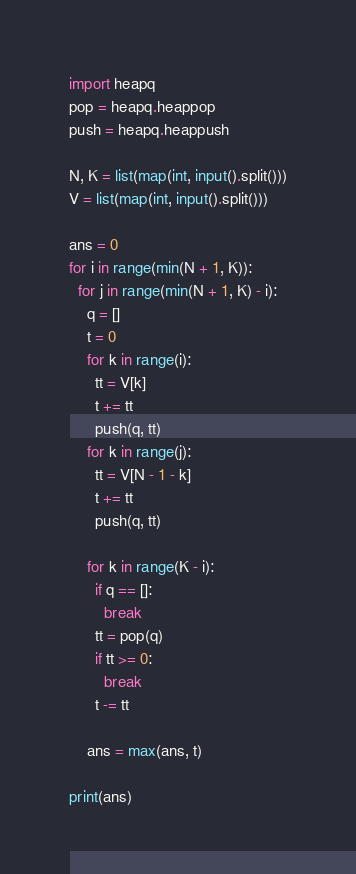Convert code to text. <code><loc_0><loc_0><loc_500><loc_500><_Python_>import heapq
pop = heapq.heappop
push = heapq.heappush

N, K = list(map(int, input().split()))
V = list(map(int, input().split()))

ans = 0
for i in range(min(N + 1, K)):
  for j in range(min(N + 1, K) - i):
    q = []
    t = 0
    for k in range(i):
      tt = V[k]
      t += tt
      push(q, tt)
    for k in range(j):
      tt = V[N - 1 - k]
      t += tt
      push(q, tt)

    for k in range(K - i):
      if q == []:
        break
      tt = pop(q)
      if tt >= 0:
        break
      t -= tt

    ans = max(ans, t)

print(ans)
</code> 